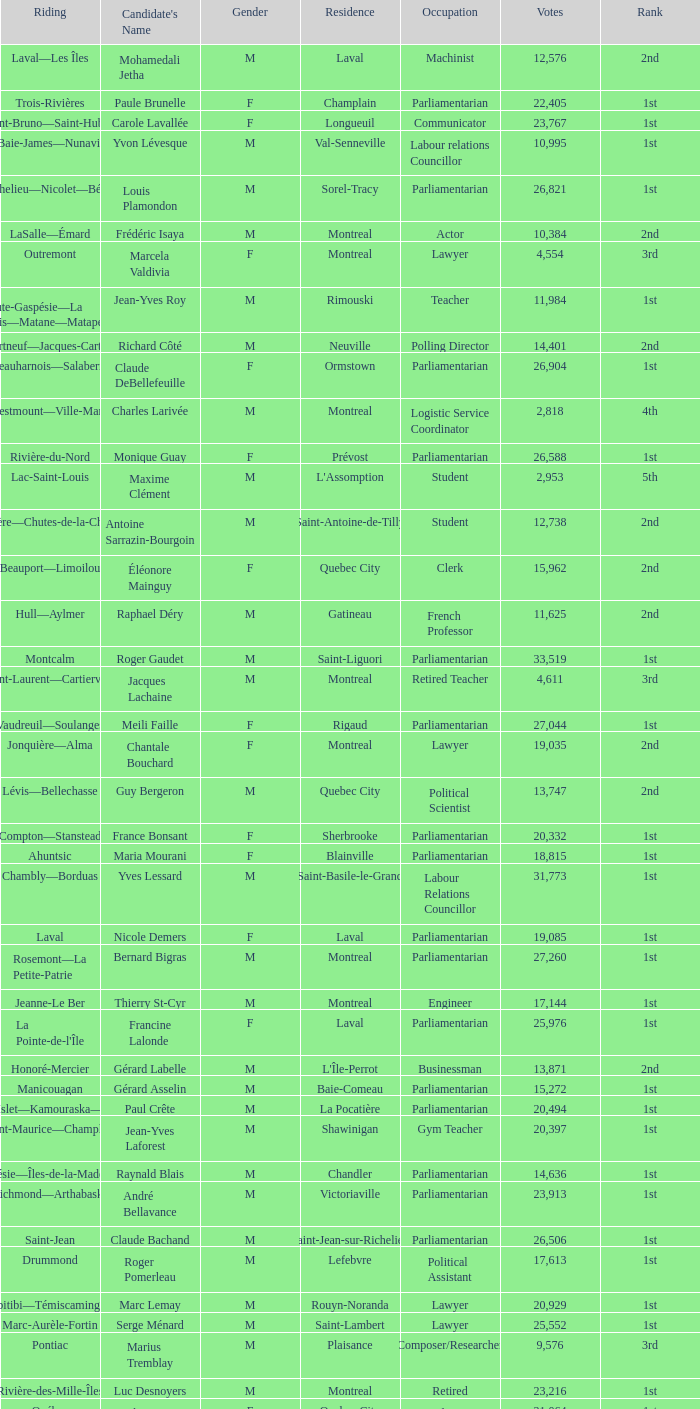What gender is Luc Desnoyers? M. 